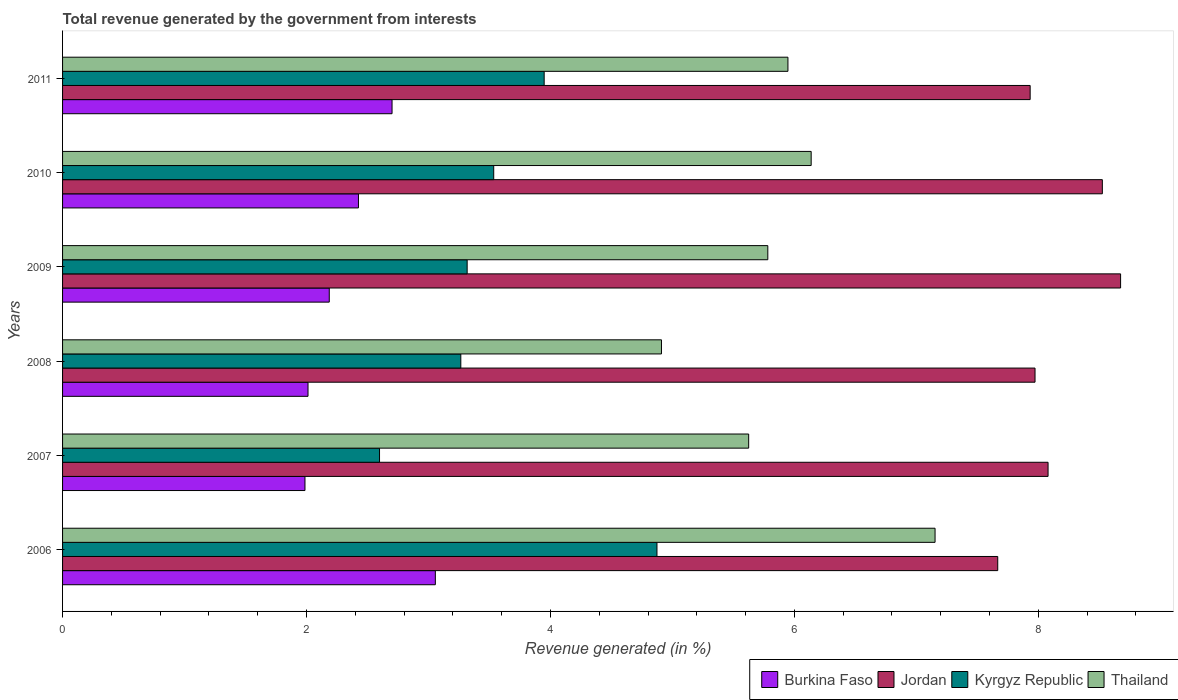How many different coloured bars are there?
Offer a very short reply. 4. How many bars are there on the 4th tick from the top?
Provide a short and direct response. 4. What is the label of the 4th group of bars from the top?
Your answer should be very brief. 2008. What is the total revenue generated in Burkina Faso in 2006?
Keep it short and to the point. 3.06. Across all years, what is the maximum total revenue generated in Burkina Faso?
Your answer should be compact. 3.06. Across all years, what is the minimum total revenue generated in Jordan?
Ensure brevity in your answer.  7.67. What is the total total revenue generated in Thailand in the graph?
Make the answer very short. 35.56. What is the difference between the total revenue generated in Kyrgyz Republic in 2006 and that in 2010?
Make the answer very short. 1.34. What is the difference between the total revenue generated in Burkina Faso in 2006 and the total revenue generated in Thailand in 2011?
Offer a terse response. -2.89. What is the average total revenue generated in Jordan per year?
Ensure brevity in your answer.  8.14. In the year 2006, what is the difference between the total revenue generated in Jordan and total revenue generated in Thailand?
Offer a very short reply. 0.51. What is the ratio of the total revenue generated in Kyrgyz Republic in 2008 to that in 2009?
Offer a very short reply. 0.98. Is the total revenue generated in Burkina Faso in 2007 less than that in 2010?
Make the answer very short. Yes. What is the difference between the highest and the second highest total revenue generated in Kyrgyz Republic?
Your answer should be compact. 0.92. What is the difference between the highest and the lowest total revenue generated in Thailand?
Ensure brevity in your answer.  2.24. Is the sum of the total revenue generated in Kyrgyz Republic in 2006 and 2008 greater than the maximum total revenue generated in Jordan across all years?
Your answer should be compact. No. What does the 4th bar from the top in 2006 represents?
Offer a very short reply. Burkina Faso. What does the 2nd bar from the bottom in 2007 represents?
Provide a short and direct response. Jordan. Is it the case that in every year, the sum of the total revenue generated in Jordan and total revenue generated in Thailand is greater than the total revenue generated in Kyrgyz Republic?
Your answer should be very brief. Yes. Are all the bars in the graph horizontal?
Provide a short and direct response. Yes. How many years are there in the graph?
Offer a terse response. 6. Are the values on the major ticks of X-axis written in scientific E-notation?
Make the answer very short. No. Does the graph contain any zero values?
Ensure brevity in your answer.  No. How many legend labels are there?
Provide a succinct answer. 4. How are the legend labels stacked?
Give a very brief answer. Horizontal. What is the title of the graph?
Offer a very short reply. Total revenue generated by the government from interests. What is the label or title of the X-axis?
Offer a terse response. Revenue generated (in %). What is the label or title of the Y-axis?
Offer a very short reply. Years. What is the Revenue generated (in %) of Burkina Faso in 2006?
Ensure brevity in your answer.  3.06. What is the Revenue generated (in %) of Jordan in 2006?
Your answer should be very brief. 7.67. What is the Revenue generated (in %) of Kyrgyz Republic in 2006?
Provide a succinct answer. 4.87. What is the Revenue generated (in %) in Thailand in 2006?
Keep it short and to the point. 7.15. What is the Revenue generated (in %) in Burkina Faso in 2007?
Your answer should be compact. 1.99. What is the Revenue generated (in %) of Jordan in 2007?
Make the answer very short. 8.08. What is the Revenue generated (in %) of Kyrgyz Republic in 2007?
Keep it short and to the point. 2.6. What is the Revenue generated (in %) of Thailand in 2007?
Provide a short and direct response. 5.63. What is the Revenue generated (in %) in Burkina Faso in 2008?
Make the answer very short. 2.01. What is the Revenue generated (in %) in Jordan in 2008?
Provide a short and direct response. 7.97. What is the Revenue generated (in %) in Kyrgyz Republic in 2008?
Give a very brief answer. 3.27. What is the Revenue generated (in %) of Thailand in 2008?
Your answer should be very brief. 4.91. What is the Revenue generated (in %) of Burkina Faso in 2009?
Provide a succinct answer. 2.19. What is the Revenue generated (in %) in Jordan in 2009?
Offer a very short reply. 8.67. What is the Revenue generated (in %) in Kyrgyz Republic in 2009?
Ensure brevity in your answer.  3.32. What is the Revenue generated (in %) in Thailand in 2009?
Provide a short and direct response. 5.78. What is the Revenue generated (in %) in Burkina Faso in 2010?
Your response must be concise. 2.43. What is the Revenue generated (in %) in Jordan in 2010?
Make the answer very short. 8.53. What is the Revenue generated (in %) in Kyrgyz Republic in 2010?
Your answer should be very brief. 3.53. What is the Revenue generated (in %) in Thailand in 2010?
Offer a very short reply. 6.14. What is the Revenue generated (in %) in Burkina Faso in 2011?
Your response must be concise. 2.7. What is the Revenue generated (in %) of Jordan in 2011?
Your answer should be compact. 7.93. What is the Revenue generated (in %) in Kyrgyz Republic in 2011?
Keep it short and to the point. 3.95. What is the Revenue generated (in %) of Thailand in 2011?
Provide a short and direct response. 5.95. Across all years, what is the maximum Revenue generated (in %) of Burkina Faso?
Ensure brevity in your answer.  3.06. Across all years, what is the maximum Revenue generated (in %) of Jordan?
Keep it short and to the point. 8.67. Across all years, what is the maximum Revenue generated (in %) of Kyrgyz Republic?
Ensure brevity in your answer.  4.87. Across all years, what is the maximum Revenue generated (in %) of Thailand?
Provide a succinct answer. 7.15. Across all years, what is the minimum Revenue generated (in %) of Burkina Faso?
Provide a succinct answer. 1.99. Across all years, what is the minimum Revenue generated (in %) in Jordan?
Offer a terse response. 7.67. Across all years, what is the minimum Revenue generated (in %) of Kyrgyz Republic?
Offer a very short reply. 2.6. Across all years, what is the minimum Revenue generated (in %) of Thailand?
Ensure brevity in your answer.  4.91. What is the total Revenue generated (in %) in Burkina Faso in the graph?
Your response must be concise. 14.37. What is the total Revenue generated (in %) in Jordan in the graph?
Ensure brevity in your answer.  48.85. What is the total Revenue generated (in %) of Kyrgyz Republic in the graph?
Your answer should be very brief. 21.54. What is the total Revenue generated (in %) in Thailand in the graph?
Provide a short and direct response. 35.56. What is the difference between the Revenue generated (in %) of Burkina Faso in 2006 and that in 2007?
Offer a terse response. 1.07. What is the difference between the Revenue generated (in %) in Jordan in 2006 and that in 2007?
Offer a very short reply. -0.41. What is the difference between the Revenue generated (in %) in Kyrgyz Republic in 2006 and that in 2007?
Provide a short and direct response. 2.27. What is the difference between the Revenue generated (in %) of Thailand in 2006 and that in 2007?
Ensure brevity in your answer.  1.53. What is the difference between the Revenue generated (in %) in Burkina Faso in 2006 and that in 2008?
Ensure brevity in your answer.  1.04. What is the difference between the Revenue generated (in %) of Jordan in 2006 and that in 2008?
Keep it short and to the point. -0.31. What is the difference between the Revenue generated (in %) of Kyrgyz Republic in 2006 and that in 2008?
Make the answer very short. 1.61. What is the difference between the Revenue generated (in %) in Thailand in 2006 and that in 2008?
Your response must be concise. 2.24. What is the difference between the Revenue generated (in %) of Burkina Faso in 2006 and that in 2009?
Offer a very short reply. 0.87. What is the difference between the Revenue generated (in %) in Jordan in 2006 and that in 2009?
Your answer should be very brief. -1.01. What is the difference between the Revenue generated (in %) in Kyrgyz Republic in 2006 and that in 2009?
Provide a succinct answer. 1.56. What is the difference between the Revenue generated (in %) of Thailand in 2006 and that in 2009?
Make the answer very short. 1.37. What is the difference between the Revenue generated (in %) of Burkina Faso in 2006 and that in 2010?
Your answer should be very brief. 0.63. What is the difference between the Revenue generated (in %) in Jordan in 2006 and that in 2010?
Keep it short and to the point. -0.86. What is the difference between the Revenue generated (in %) of Kyrgyz Republic in 2006 and that in 2010?
Offer a terse response. 1.34. What is the difference between the Revenue generated (in %) of Thailand in 2006 and that in 2010?
Keep it short and to the point. 1.02. What is the difference between the Revenue generated (in %) in Burkina Faso in 2006 and that in 2011?
Provide a short and direct response. 0.35. What is the difference between the Revenue generated (in %) in Jordan in 2006 and that in 2011?
Your answer should be compact. -0.27. What is the difference between the Revenue generated (in %) in Kyrgyz Republic in 2006 and that in 2011?
Give a very brief answer. 0.92. What is the difference between the Revenue generated (in %) in Thailand in 2006 and that in 2011?
Provide a short and direct response. 1.21. What is the difference between the Revenue generated (in %) in Burkina Faso in 2007 and that in 2008?
Provide a succinct answer. -0.02. What is the difference between the Revenue generated (in %) in Jordan in 2007 and that in 2008?
Your answer should be very brief. 0.11. What is the difference between the Revenue generated (in %) of Kyrgyz Republic in 2007 and that in 2008?
Ensure brevity in your answer.  -0.67. What is the difference between the Revenue generated (in %) in Thailand in 2007 and that in 2008?
Give a very brief answer. 0.72. What is the difference between the Revenue generated (in %) in Burkina Faso in 2007 and that in 2009?
Ensure brevity in your answer.  -0.2. What is the difference between the Revenue generated (in %) of Jordan in 2007 and that in 2009?
Keep it short and to the point. -0.59. What is the difference between the Revenue generated (in %) in Kyrgyz Republic in 2007 and that in 2009?
Offer a very short reply. -0.72. What is the difference between the Revenue generated (in %) of Thailand in 2007 and that in 2009?
Provide a succinct answer. -0.16. What is the difference between the Revenue generated (in %) of Burkina Faso in 2007 and that in 2010?
Your response must be concise. -0.44. What is the difference between the Revenue generated (in %) in Jordan in 2007 and that in 2010?
Your answer should be compact. -0.45. What is the difference between the Revenue generated (in %) of Kyrgyz Republic in 2007 and that in 2010?
Your answer should be compact. -0.94. What is the difference between the Revenue generated (in %) of Thailand in 2007 and that in 2010?
Offer a very short reply. -0.51. What is the difference between the Revenue generated (in %) of Burkina Faso in 2007 and that in 2011?
Provide a succinct answer. -0.71. What is the difference between the Revenue generated (in %) of Jordan in 2007 and that in 2011?
Your answer should be compact. 0.15. What is the difference between the Revenue generated (in %) of Kyrgyz Republic in 2007 and that in 2011?
Keep it short and to the point. -1.35. What is the difference between the Revenue generated (in %) of Thailand in 2007 and that in 2011?
Offer a terse response. -0.32. What is the difference between the Revenue generated (in %) in Burkina Faso in 2008 and that in 2009?
Your answer should be very brief. -0.17. What is the difference between the Revenue generated (in %) in Jordan in 2008 and that in 2009?
Your response must be concise. -0.7. What is the difference between the Revenue generated (in %) of Kyrgyz Republic in 2008 and that in 2009?
Your response must be concise. -0.05. What is the difference between the Revenue generated (in %) of Thailand in 2008 and that in 2009?
Provide a succinct answer. -0.87. What is the difference between the Revenue generated (in %) in Burkina Faso in 2008 and that in 2010?
Ensure brevity in your answer.  -0.41. What is the difference between the Revenue generated (in %) of Jordan in 2008 and that in 2010?
Provide a succinct answer. -0.55. What is the difference between the Revenue generated (in %) in Kyrgyz Republic in 2008 and that in 2010?
Offer a very short reply. -0.27. What is the difference between the Revenue generated (in %) of Thailand in 2008 and that in 2010?
Provide a succinct answer. -1.23. What is the difference between the Revenue generated (in %) of Burkina Faso in 2008 and that in 2011?
Make the answer very short. -0.69. What is the difference between the Revenue generated (in %) in Jordan in 2008 and that in 2011?
Ensure brevity in your answer.  0.04. What is the difference between the Revenue generated (in %) in Kyrgyz Republic in 2008 and that in 2011?
Keep it short and to the point. -0.68. What is the difference between the Revenue generated (in %) of Thailand in 2008 and that in 2011?
Provide a short and direct response. -1.04. What is the difference between the Revenue generated (in %) in Burkina Faso in 2009 and that in 2010?
Offer a very short reply. -0.24. What is the difference between the Revenue generated (in %) of Jordan in 2009 and that in 2010?
Ensure brevity in your answer.  0.15. What is the difference between the Revenue generated (in %) of Kyrgyz Republic in 2009 and that in 2010?
Your answer should be very brief. -0.22. What is the difference between the Revenue generated (in %) in Thailand in 2009 and that in 2010?
Offer a terse response. -0.36. What is the difference between the Revenue generated (in %) in Burkina Faso in 2009 and that in 2011?
Keep it short and to the point. -0.51. What is the difference between the Revenue generated (in %) in Jordan in 2009 and that in 2011?
Your response must be concise. 0.74. What is the difference between the Revenue generated (in %) in Kyrgyz Republic in 2009 and that in 2011?
Offer a terse response. -0.63. What is the difference between the Revenue generated (in %) in Thailand in 2009 and that in 2011?
Provide a short and direct response. -0.17. What is the difference between the Revenue generated (in %) of Burkina Faso in 2010 and that in 2011?
Offer a very short reply. -0.28. What is the difference between the Revenue generated (in %) in Jordan in 2010 and that in 2011?
Keep it short and to the point. 0.59. What is the difference between the Revenue generated (in %) in Kyrgyz Republic in 2010 and that in 2011?
Your response must be concise. -0.41. What is the difference between the Revenue generated (in %) in Thailand in 2010 and that in 2011?
Keep it short and to the point. 0.19. What is the difference between the Revenue generated (in %) in Burkina Faso in 2006 and the Revenue generated (in %) in Jordan in 2007?
Ensure brevity in your answer.  -5.02. What is the difference between the Revenue generated (in %) in Burkina Faso in 2006 and the Revenue generated (in %) in Kyrgyz Republic in 2007?
Keep it short and to the point. 0.46. What is the difference between the Revenue generated (in %) in Burkina Faso in 2006 and the Revenue generated (in %) in Thailand in 2007?
Your answer should be very brief. -2.57. What is the difference between the Revenue generated (in %) of Jordan in 2006 and the Revenue generated (in %) of Kyrgyz Republic in 2007?
Ensure brevity in your answer.  5.07. What is the difference between the Revenue generated (in %) of Jordan in 2006 and the Revenue generated (in %) of Thailand in 2007?
Keep it short and to the point. 2.04. What is the difference between the Revenue generated (in %) in Kyrgyz Republic in 2006 and the Revenue generated (in %) in Thailand in 2007?
Your answer should be very brief. -0.75. What is the difference between the Revenue generated (in %) in Burkina Faso in 2006 and the Revenue generated (in %) in Jordan in 2008?
Provide a short and direct response. -4.92. What is the difference between the Revenue generated (in %) in Burkina Faso in 2006 and the Revenue generated (in %) in Kyrgyz Republic in 2008?
Offer a very short reply. -0.21. What is the difference between the Revenue generated (in %) of Burkina Faso in 2006 and the Revenue generated (in %) of Thailand in 2008?
Provide a short and direct response. -1.85. What is the difference between the Revenue generated (in %) in Jordan in 2006 and the Revenue generated (in %) in Kyrgyz Republic in 2008?
Your answer should be compact. 4.4. What is the difference between the Revenue generated (in %) in Jordan in 2006 and the Revenue generated (in %) in Thailand in 2008?
Your response must be concise. 2.76. What is the difference between the Revenue generated (in %) of Kyrgyz Republic in 2006 and the Revenue generated (in %) of Thailand in 2008?
Keep it short and to the point. -0.04. What is the difference between the Revenue generated (in %) of Burkina Faso in 2006 and the Revenue generated (in %) of Jordan in 2009?
Make the answer very short. -5.62. What is the difference between the Revenue generated (in %) in Burkina Faso in 2006 and the Revenue generated (in %) in Kyrgyz Republic in 2009?
Give a very brief answer. -0.26. What is the difference between the Revenue generated (in %) of Burkina Faso in 2006 and the Revenue generated (in %) of Thailand in 2009?
Provide a succinct answer. -2.73. What is the difference between the Revenue generated (in %) in Jordan in 2006 and the Revenue generated (in %) in Kyrgyz Republic in 2009?
Offer a very short reply. 4.35. What is the difference between the Revenue generated (in %) in Jordan in 2006 and the Revenue generated (in %) in Thailand in 2009?
Keep it short and to the point. 1.89. What is the difference between the Revenue generated (in %) of Kyrgyz Republic in 2006 and the Revenue generated (in %) of Thailand in 2009?
Make the answer very short. -0.91. What is the difference between the Revenue generated (in %) of Burkina Faso in 2006 and the Revenue generated (in %) of Jordan in 2010?
Offer a very short reply. -5.47. What is the difference between the Revenue generated (in %) of Burkina Faso in 2006 and the Revenue generated (in %) of Kyrgyz Republic in 2010?
Provide a succinct answer. -0.48. What is the difference between the Revenue generated (in %) in Burkina Faso in 2006 and the Revenue generated (in %) in Thailand in 2010?
Give a very brief answer. -3.08. What is the difference between the Revenue generated (in %) of Jordan in 2006 and the Revenue generated (in %) of Kyrgyz Republic in 2010?
Your answer should be compact. 4.13. What is the difference between the Revenue generated (in %) in Jordan in 2006 and the Revenue generated (in %) in Thailand in 2010?
Offer a terse response. 1.53. What is the difference between the Revenue generated (in %) of Kyrgyz Republic in 2006 and the Revenue generated (in %) of Thailand in 2010?
Provide a succinct answer. -1.26. What is the difference between the Revenue generated (in %) of Burkina Faso in 2006 and the Revenue generated (in %) of Jordan in 2011?
Give a very brief answer. -4.88. What is the difference between the Revenue generated (in %) in Burkina Faso in 2006 and the Revenue generated (in %) in Kyrgyz Republic in 2011?
Your response must be concise. -0.89. What is the difference between the Revenue generated (in %) of Burkina Faso in 2006 and the Revenue generated (in %) of Thailand in 2011?
Your answer should be very brief. -2.89. What is the difference between the Revenue generated (in %) of Jordan in 2006 and the Revenue generated (in %) of Kyrgyz Republic in 2011?
Ensure brevity in your answer.  3.72. What is the difference between the Revenue generated (in %) in Jordan in 2006 and the Revenue generated (in %) in Thailand in 2011?
Your answer should be very brief. 1.72. What is the difference between the Revenue generated (in %) in Kyrgyz Republic in 2006 and the Revenue generated (in %) in Thailand in 2011?
Give a very brief answer. -1.07. What is the difference between the Revenue generated (in %) of Burkina Faso in 2007 and the Revenue generated (in %) of Jordan in 2008?
Make the answer very short. -5.99. What is the difference between the Revenue generated (in %) of Burkina Faso in 2007 and the Revenue generated (in %) of Kyrgyz Republic in 2008?
Give a very brief answer. -1.28. What is the difference between the Revenue generated (in %) of Burkina Faso in 2007 and the Revenue generated (in %) of Thailand in 2008?
Keep it short and to the point. -2.92. What is the difference between the Revenue generated (in %) in Jordan in 2007 and the Revenue generated (in %) in Kyrgyz Republic in 2008?
Make the answer very short. 4.81. What is the difference between the Revenue generated (in %) in Jordan in 2007 and the Revenue generated (in %) in Thailand in 2008?
Ensure brevity in your answer.  3.17. What is the difference between the Revenue generated (in %) in Kyrgyz Republic in 2007 and the Revenue generated (in %) in Thailand in 2008?
Provide a short and direct response. -2.31. What is the difference between the Revenue generated (in %) of Burkina Faso in 2007 and the Revenue generated (in %) of Jordan in 2009?
Give a very brief answer. -6.69. What is the difference between the Revenue generated (in %) of Burkina Faso in 2007 and the Revenue generated (in %) of Kyrgyz Republic in 2009?
Offer a very short reply. -1.33. What is the difference between the Revenue generated (in %) of Burkina Faso in 2007 and the Revenue generated (in %) of Thailand in 2009?
Offer a terse response. -3.79. What is the difference between the Revenue generated (in %) in Jordan in 2007 and the Revenue generated (in %) in Kyrgyz Republic in 2009?
Provide a succinct answer. 4.76. What is the difference between the Revenue generated (in %) in Jordan in 2007 and the Revenue generated (in %) in Thailand in 2009?
Your response must be concise. 2.3. What is the difference between the Revenue generated (in %) of Kyrgyz Republic in 2007 and the Revenue generated (in %) of Thailand in 2009?
Make the answer very short. -3.18. What is the difference between the Revenue generated (in %) in Burkina Faso in 2007 and the Revenue generated (in %) in Jordan in 2010?
Your response must be concise. -6.54. What is the difference between the Revenue generated (in %) of Burkina Faso in 2007 and the Revenue generated (in %) of Kyrgyz Republic in 2010?
Offer a very short reply. -1.55. What is the difference between the Revenue generated (in %) in Burkina Faso in 2007 and the Revenue generated (in %) in Thailand in 2010?
Provide a short and direct response. -4.15. What is the difference between the Revenue generated (in %) of Jordan in 2007 and the Revenue generated (in %) of Kyrgyz Republic in 2010?
Ensure brevity in your answer.  4.55. What is the difference between the Revenue generated (in %) of Jordan in 2007 and the Revenue generated (in %) of Thailand in 2010?
Make the answer very short. 1.94. What is the difference between the Revenue generated (in %) in Kyrgyz Republic in 2007 and the Revenue generated (in %) in Thailand in 2010?
Your answer should be compact. -3.54. What is the difference between the Revenue generated (in %) in Burkina Faso in 2007 and the Revenue generated (in %) in Jordan in 2011?
Provide a succinct answer. -5.95. What is the difference between the Revenue generated (in %) in Burkina Faso in 2007 and the Revenue generated (in %) in Kyrgyz Republic in 2011?
Ensure brevity in your answer.  -1.96. What is the difference between the Revenue generated (in %) in Burkina Faso in 2007 and the Revenue generated (in %) in Thailand in 2011?
Give a very brief answer. -3.96. What is the difference between the Revenue generated (in %) of Jordan in 2007 and the Revenue generated (in %) of Kyrgyz Republic in 2011?
Make the answer very short. 4.13. What is the difference between the Revenue generated (in %) in Jordan in 2007 and the Revenue generated (in %) in Thailand in 2011?
Give a very brief answer. 2.13. What is the difference between the Revenue generated (in %) in Kyrgyz Republic in 2007 and the Revenue generated (in %) in Thailand in 2011?
Your response must be concise. -3.35. What is the difference between the Revenue generated (in %) of Burkina Faso in 2008 and the Revenue generated (in %) of Jordan in 2009?
Ensure brevity in your answer.  -6.66. What is the difference between the Revenue generated (in %) of Burkina Faso in 2008 and the Revenue generated (in %) of Kyrgyz Republic in 2009?
Your response must be concise. -1.3. What is the difference between the Revenue generated (in %) of Burkina Faso in 2008 and the Revenue generated (in %) of Thailand in 2009?
Ensure brevity in your answer.  -3.77. What is the difference between the Revenue generated (in %) of Jordan in 2008 and the Revenue generated (in %) of Kyrgyz Republic in 2009?
Keep it short and to the point. 4.66. What is the difference between the Revenue generated (in %) of Jordan in 2008 and the Revenue generated (in %) of Thailand in 2009?
Offer a very short reply. 2.19. What is the difference between the Revenue generated (in %) of Kyrgyz Republic in 2008 and the Revenue generated (in %) of Thailand in 2009?
Ensure brevity in your answer.  -2.52. What is the difference between the Revenue generated (in %) of Burkina Faso in 2008 and the Revenue generated (in %) of Jordan in 2010?
Keep it short and to the point. -6.51. What is the difference between the Revenue generated (in %) of Burkina Faso in 2008 and the Revenue generated (in %) of Kyrgyz Republic in 2010?
Give a very brief answer. -1.52. What is the difference between the Revenue generated (in %) in Burkina Faso in 2008 and the Revenue generated (in %) in Thailand in 2010?
Provide a short and direct response. -4.13. What is the difference between the Revenue generated (in %) of Jordan in 2008 and the Revenue generated (in %) of Kyrgyz Republic in 2010?
Your response must be concise. 4.44. What is the difference between the Revenue generated (in %) of Jordan in 2008 and the Revenue generated (in %) of Thailand in 2010?
Make the answer very short. 1.84. What is the difference between the Revenue generated (in %) in Kyrgyz Republic in 2008 and the Revenue generated (in %) in Thailand in 2010?
Your response must be concise. -2.87. What is the difference between the Revenue generated (in %) in Burkina Faso in 2008 and the Revenue generated (in %) in Jordan in 2011?
Your answer should be very brief. -5.92. What is the difference between the Revenue generated (in %) in Burkina Faso in 2008 and the Revenue generated (in %) in Kyrgyz Republic in 2011?
Give a very brief answer. -1.94. What is the difference between the Revenue generated (in %) of Burkina Faso in 2008 and the Revenue generated (in %) of Thailand in 2011?
Offer a very short reply. -3.93. What is the difference between the Revenue generated (in %) in Jordan in 2008 and the Revenue generated (in %) in Kyrgyz Republic in 2011?
Your answer should be compact. 4.02. What is the difference between the Revenue generated (in %) of Jordan in 2008 and the Revenue generated (in %) of Thailand in 2011?
Ensure brevity in your answer.  2.03. What is the difference between the Revenue generated (in %) in Kyrgyz Republic in 2008 and the Revenue generated (in %) in Thailand in 2011?
Give a very brief answer. -2.68. What is the difference between the Revenue generated (in %) in Burkina Faso in 2009 and the Revenue generated (in %) in Jordan in 2010?
Your answer should be very brief. -6.34. What is the difference between the Revenue generated (in %) in Burkina Faso in 2009 and the Revenue generated (in %) in Kyrgyz Republic in 2010?
Offer a terse response. -1.35. What is the difference between the Revenue generated (in %) of Burkina Faso in 2009 and the Revenue generated (in %) of Thailand in 2010?
Ensure brevity in your answer.  -3.95. What is the difference between the Revenue generated (in %) of Jordan in 2009 and the Revenue generated (in %) of Kyrgyz Republic in 2010?
Give a very brief answer. 5.14. What is the difference between the Revenue generated (in %) of Jordan in 2009 and the Revenue generated (in %) of Thailand in 2010?
Provide a short and direct response. 2.54. What is the difference between the Revenue generated (in %) of Kyrgyz Republic in 2009 and the Revenue generated (in %) of Thailand in 2010?
Offer a terse response. -2.82. What is the difference between the Revenue generated (in %) of Burkina Faso in 2009 and the Revenue generated (in %) of Jordan in 2011?
Provide a succinct answer. -5.75. What is the difference between the Revenue generated (in %) in Burkina Faso in 2009 and the Revenue generated (in %) in Kyrgyz Republic in 2011?
Offer a very short reply. -1.76. What is the difference between the Revenue generated (in %) of Burkina Faso in 2009 and the Revenue generated (in %) of Thailand in 2011?
Provide a succinct answer. -3.76. What is the difference between the Revenue generated (in %) in Jordan in 2009 and the Revenue generated (in %) in Kyrgyz Republic in 2011?
Your response must be concise. 4.73. What is the difference between the Revenue generated (in %) of Jordan in 2009 and the Revenue generated (in %) of Thailand in 2011?
Provide a succinct answer. 2.73. What is the difference between the Revenue generated (in %) in Kyrgyz Republic in 2009 and the Revenue generated (in %) in Thailand in 2011?
Make the answer very short. -2.63. What is the difference between the Revenue generated (in %) of Burkina Faso in 2010 and the Revenue generated (in %) of Jordan in 2011?
Ensure brevity in your answer.  -5.51. What is the difference between the Revenue generated (in %) in Burkina Faso in 2010 and the Revenue generated (in %) in Kyrgyz Republic in 2011?
Give a very brief answer. -1.52. What is the difference between the Revenue generated (in %) in Burkina Faso in 2010 and the Revenue generated (in %) in Thailand in 2011?
Your response must be concise. -3.52. What is the difference between the Revenue generated (in %) in Jordan in 2010 and the Revenue generated (in %) in Kyrgyz Republic in 2011?
Your answer should be very brief. 4.58. What is the difference between the Revenue generated (in %) of Jordan in 2010 and the Revenue generated (in %) of Thailand in 2011?
Your answer should be compact. 2.58. What is the difference between the Revenue generated (in %) of Kyrgyz Republic in 2010 and the Revenue generated (in %) of Thailand in 2011?
Provide a succinct answer. -2.41. What is the average Revenue generated (in %) in Burkina Faso per year?
Your answer should be very brief. 2.4. What is the average Revenue generated (in %) in Jordan per year?
Give a very brief answer. 8.14. What is the average Revenue generated (in %) in Kyrgyz Republic per year?
Keep it short and to the point. 3.59. What is the average Revenue generated (in %) in Thailand per year?
Keep it short and to the point. 5.93. In the year 2006, what is the difference between the Revenue generated (in %) of Burkina Faso and Revenue generated (in %) of Jordan?
Offer a terse response. -4.61. In the year 2006, what is the difference between the Revenue generated (in %) of Burkina Faso and Revenue generated (in %) of Kyrgyz Republic?
Keep it short and to the point. -1.82. In the year 2006, what is the difference between the Revenue generated (in %) of Burkina Faso and Revenue generated (in %) of Thailand?
Ensure brevity in your answer.  -4.1. In the year 2006, what is the difference between the Revenue generated (in %) of Jordan and Revenue generated (in %) of Kyrgyz Republic?
Provide a succinct answer. 2.79. In the year 2006, what is the difference between the Revenue generated (in %) in Jordan and Revenue generated (in %) in Thailand?
Ensure brevity in your answer.  0.51. In the year 2006, what is the difference between the Revenue generated (in %) in Kyrgyz Republic and Revenue generated (in %) in Thailand?
Provide a short and direct response. -2.28. In the year 2007, what is the difference between the Revenue generated (in %) of Burkina Faso and Revenue generated (in %) of Jordan?
Provide a succinct answer. -6.09. In the year 2007, what is the difference between the Revenue generated (in %) of Burkina Faso and Revenue generated (in %) of Kyrgyz Republic?
Provide a short and direct response. -0.61. In the year 2007, what is the difference between the Revenue generated (in %) of Burkina Faso and Revenue generated (in %) of Thailand?
Give a very brief answer. -3.64. In the year 2007, what is the difference between the Revenue generated (in %) of Jordan and Revenue generated (in %) of Kyrgyz Republic?
Provide a short and direct response. 5.48. In the year 2007, what is the difference between the Revenue generated (in %) of Jordan and Revenue generated (in %) of Thailand?
Ensure brevity in your answer.  2.45. In the year 2007, what is the difference between the Revenue generated (in %) in Kyrgyz Republic and Revenue generated (in %) in Thailand?
Your response must be concise. -3.03. In the year 2008, what is the difference between the Revenue generated (in %) in Burkina Faso and Revenue generated (in %) in Jordan?
Provide a succinct answer. -5.96. In the year 2008, what is the difference between the Revenue generated (in %) in Burkina Faso and Revenue generated (in %) in Kyrgyz Republic?
Provide a succinct answer. -1.25. In the year 2008, what is the difference between the Revenue generated (in %) in Burkina Faso and Revenue generated (in %) in Thailand?
Make the answer very short. -2.9. In the year 2008, what is the difference between the Revenue generated (in %) of Jordan and Revenue generated (in %) of Kyrgyz Republic?
Provide a short and direct response. 4.71. In the year 2008, what is the difference between the Revenue generated (in %) of Jordan and Revenue generated (in %) of Thailand?
Your answer should be very brief. 3.06. In the year 2008, what is the difference between the Revenue generated (in %) of Kyrgyz Republic and Revenue generated (in %) of Thailand?
Keep it short and to the point. -1.65. In the year 2009, what is the difference between the Revenue generated (in %) in Burkina Faso and Revenue generated (in %) in Jordan?
Your answer should be very brief. -6.49. In the year 2009, what is the difference between the Revenue generated (in %) in Burkina Faso and Revenue generated (in %) in Kyrgyz Republic?
Ensure brevity in your answer.  -1.13. In the year 2009, what is the difference between the Revenue generated (in %) of Burkina Faso and Revenue generated (in %) of Thailand?
Make the answer very short. -3.6. In the year 2009, what is the difference between the Revenue generated (in %) of Jordan and Revenue generated (in %) of Kyrgyz Republic?
Offer a terse response. 5.36. In the year 2009, what is the difference between the Revenue generated (in %) in Jordan and Revenue generated (in %) in Thailand?
Keep it short and to the point. 2.89. In the year 2009, what is the difference between the Revenue generated (in %) of Kyrgyz Republic and Revenue generated (in %) of Thailand?
Give a very brief answer. -2.47. In the year 2010, what is the difference between the Revenue generated (in %) of Burkina Faso and Revenue generated (in %) of Jordan?
Your answer should be compact. -6.1. In the year 2010, what is the difference between the Revenue generated (in %) of Burkina Faso and Revenue generated (in %) of Kyrgyz Republic?
Provide a succinct answer. -1.11. In the year 2010, what is the difference between the Revenue generated (in %) in Burkina Faso and Revenue generated (in %) in Thailand?
Your answer should be very brief. -3.71. In the year 2010, what is the difference between the Revenue generated (in %) of Jordan and Revenue generated (in %) of Kyrgyz Republic?
Provide a succinct answer. 4.99. In the year 2010, what is the difference between the Revenue generated (in %) of Jordan and Revenue generated (in %) of Thailand?
Your answer should be compact. 2.39. In the year 2010, what is the difference between the Revenue generated (in %) in Kyrgyz Republic and Revenue generated (in %) in Thailand?
Provide a short and direct response. -2.6. In the year 2011, what is the difference between the Revenue generated (in %) in Burkina Faso and Revenue generated (in %) in Jordan?
Provide a short and direct response. -5.23. In the year 2011, what is the difference between the Revenue generated (in %) of Burkina Faso and Revenue generated (in %) of Kyrgyz Republic?
Offer a terse response. -1.25. In the year 2011, what is the difference between the Revenue generated (in %) of Burkina Faso and Revenue generated (in %) of Thailand?
Make the answer very short. -3.25. In the year 2011, what is the difference between the Revenue generated (in %) of Jordan and Revenue generated (in %) of Kyrgyz Republic?
Your answer should be compact. 3.98. In the year 2011, what is the difference between the Revenue generated (in %) in Jordan and Revenue generated (in %) in Thailand?
Your answer should be compact. 1.99. In the year 2011, what is the difference between the Revenue generated (in %) of Kyrgyz Republic and Revenue generated (in %) of Thailand?
Make the answer very short. -2. What is the ratio of the Revenue generated (in %) of Burkina Faso in 2006 to that in 2007?
Offer a terse response. 1.54. What is the ratio of the Revenue generated (in %) of Jordan in 2006 to that in 2007?
Your response must be concise. 0.95. What is the ratio of the Revenue generated (in %) of Kyrgyz Republic in 2006 to that in 2007?
Your response must be concise. 1.88. What is the ratio of the Revenue generated (in %) in Thailand in 2006 to that in 2007?
Make the answer very short. 1.27. What is the ratio of the Revenue generated (in %) in Burkina Faso in 2006 to that in 2008?
Your response must be concise. 1.52. What is the ratio of the Revenue generated (in %) of Jordan in 2006 to that in 2008?
Provide a short and direct response. 0.96. What is the ratio of the Revenue generated (in %) of Kyrgyz Republic in 2006 to that in 2008?
Your answer should be compact. 1.49. What is the ratio of the Revenue generated (in %) in Thailand in 2006 to that in 2008?
Provide a short and direct response. 1.46. What is the ratio of the Revenue generated (in %) in Burkina Faso in 2006 to that in 2009?
Offer a very short reply. 1.4. What is the ratio of the Revenue generated (in %) in Jordan in 2006 to that in 2009?
Offer a very short reply. 0.88. What is the ratio of the Revenue generated (in %) of Kyrgyz Republic in 2006 to that in 2009?
Provide a short and direct response. 1.47. What is the ratio of the Revenue generated (in %) in Thailand in 2006 to that in 2009?
Provide a succinct answer. 1.24. What is the ratio of the Revenue generated (in %) in Burkina Faso in 2006 to that in 2010?
Offer a terse response. 1.26. What is the ratio of the Revenue generated (in %) of Jordan in 2006 to that in 2010?
Your response must be concise. 0.9. What is the ratio of the Revenue generated (in %) of Kyrgyz Republic in 2006 to that in 2010?
Your answer should be very brief. 1.38. What is the ratio of the Revenue generated (in %) in Thailand in 2006 to that in 2010?
Your answer should be very brief. 1.17. What is the ratio of the Revenue generated (in %) of Burkina Faso in 2006 to that in 2011?
Provide a short and direct response. 1.13. What is the ratio of the Revenue generated (in %) of Jordan in 2006 to that in 2011?
Your answer should be compact. 0.97. What is the ratio of the Revenue generated (in %) in Kyrgyz Republic in 2006 to that in 2011?
Your answer should be compact. 1.23. What is the ratio of the Revenue generated (in %) of Thailand in 2006 to that in 2011?
Your response must be concise. 1.2. What is the ratio of the Revenue generated (in %) of Burkina Faso in 2007 to that in 2008?
Keep it short and to the point. 0.99. What is the ratio of the Revenue generated (in %) of Jordan in 2007 to that in 2008?
Your answer should be very brief. 1.01. What is the ratio of the Revenue generated (in %) of Kyrgyz Republic in 2007 to that in 2008?
Your answer should be compact. 0.8. What is the ratio of the Revenue generated (in %) in Thailand in 2007 to that in 2008?
Provide a short and direct response. 1.15. What is the ratio of the Revenue generated (in %) in Burkina Faso in 2007 to that in 2009?
Offer a very short reply. 0.91. What is the ratio of the Revenue generated (in %) of Jordan in 2007 to that in 2009?
Give a very brief answer. 0.93. What is the ratio of the Revenue generated (in %) of Kyrgyz Republic in 2007 to that in 2009?
Ensure brevity in your answer.  0.78. What is the ratio of the Revenue generated (in %) in Thailand in 2007 to that in 2009?
Offer a very short reply. 0.97. What is the ratio of the Revenue generated (in %) in Burkina Faso in 2007 to that in 2010?
Make the answer very short. 0.82. What is the ratio of the Revenue generated (in %) of Jordan in 2007 to that in 2010?
Give a very brief answer. 0.95. What is the ratio of the Revenue generated (in %) of Kyrgyz Republic in 2007 to that in 2010?
Ensure brevity in your answer.  0.74. What is the ratio of the Revenue generated (in %) of Thailand in 2007 to that in 2010?
Offer a very short reply. 0.92. What is the ratio of the Revenue generated (in %) in Burkina Faso in 2007 to that in 2011?
Make the answer very short. 0.74. What is the ratio of the Revenue generated (in %) of Jordan in 2007 to that in 2011?
Give a very brief answer. 1.02. What is the ratio of the Revenue generated (in %) in Kyrgyz Republic in 2007 to that in 2011?
Keep it short and to the point. 0.66. What is the ratio of the Revenue generated (in %) in Thailand in 2007 to that in 2011?
Your answer should be very brief. 0.95. What is the ratio of the Revenue generated (in %) in Burkina Faso in 2008 to that in 2009?
Your answer should be compact. 0.92. What is the ratio of the Revenue generated (in %) of Jordan in 2008 to that in 2009?
Offer a very short reply. 0.92. What is the ratio of the Revenue generated (in %) of Kyrgyz Republic in 2008 to that in 2009?
Your answer should be very brief. 0.98. What is the ratio of the Revenue generated (in %) of Thailand in 2008 to that in 2009?
Ensure brevity in your answer.  0.85. What is the ratio of the Revenue generated (in %) of Burkina Faso in 2008 to that in 2010?
Offer a terse response. 0.83. What is the ratio of the Revenue generated (in %) in Jordan in 2008 to that in 2010?
Provide a succinct answer. 0.94. What is the ratio of the Revenue generated (in %) of Kyrgyz Republic in 2008 to that in 2010?
Your answer should be very brief. 0.92. What is the ratio of the Revenue generated (in %) of Thailand in 2008 to that in 2010?
Provide a short and direct response. 0.8. What is the ratio of the Revenue generated (in %) in Burkina Faso in 2008 to that in 2011?
Make the answer very short. 0.74. What is the ratio of the Revenue generated (in %) of Jordan in 2008 to that in 2011?
Make the answer very short. 1. What is the ratio of the Revenue generated (in %) of Kyrgyz Republic in 2008 to that in 2011?
Provide a succinct answer. 0.83. What is the ratio of the Revenue generated (in %) in Thailand in 2008 to that in 2011?
Give a very brief answer. 0.83. What is the ratio of the Revenue generated (in %) of Burkina Faso in 2009 to that in 2010?
Give a very brief answer. 0.9. What is the ratio of the Revenue generated (in %) in Jordan in 2009 to that in 2010?
Make the answer very short. 1.02. What is the ratio of the Revenue generated (in %) of Kyrgyz Republic in 2009 to that in 2010?
Provide a short and direct response. 0.94. What is the ratio of the Revenue generated (in %) of Thailand in 2009 to that in 2010?
Give a very brief answer. 0.94. What is the ratio of the Revenue generated (in %) in Burkina Faso in 2009 to that in 2011?
Offer a very short reply. 0.81. What is the ratio of the Revenue generated (in %) of Jordan in 2009 to that in 2011?
Make the answer very short. 1.09. What is the ratio of the Revenue generated (in %) of Kyrgyz Republic in 2009 to that in 2011?
Your answer should be compact. 0.84. What is the ratio of the Revenue generated (in %) in Thailand in 2009 to that in 2011?
Keep it short and to the point. 0.97. What is the ratio of the Revenue generated (in %) in Burkina Faso in 2010 to that in 2011?
Give a very brief answer. 0.9. What is the ratio of the Revenue generated (in %) in Jordan in 2010 to that in 2011?
Make the answer very short. 1.07. What is the ratio of the Revenue generated (in %) of Kyrgyz Republic in 2010 to that in 2011?
Provide a short and direct response. 0.9. What is the ratio of the Revenue generated (in %) of Thailand in 2010 to that in 2011?
Keep it short and to the point. 1.03. What is the difference between the highest and the second highest Revenue generated (in %) of Burkina Faso?
Provide a short and direct response. 0.35. What is the difference between the highest and the second highest Revenue generated (in %) of Jordan?
Give a very brief answer. 0.15. What is the difference between the highest and the second highest Revenue generated (in %) in Kyrgyz Republic?
Make the answer very short. 0.92. What is the difference between the highest and the second highest Revenue generated (in %) in Thailand?
Provide a short and direct response. 1.02. What is the difference between the highest and the lowest Revenue generated (in %) in Burkina Faso?
Your answer should be very brief. 1.07. What is the difference between the highest and the lowest Revenue generated (in %) of Jordan?
Offer a very short reply. 1.01. What is the difference between the highest and the lowest Revenue generated (in %) of Kyrgyz Republic?
Your answer should be very brief. 2.27. What is the difference between the highest and the lowest Revenue generated (in %) of Thailand?
Your response must be concise. 2.24. 